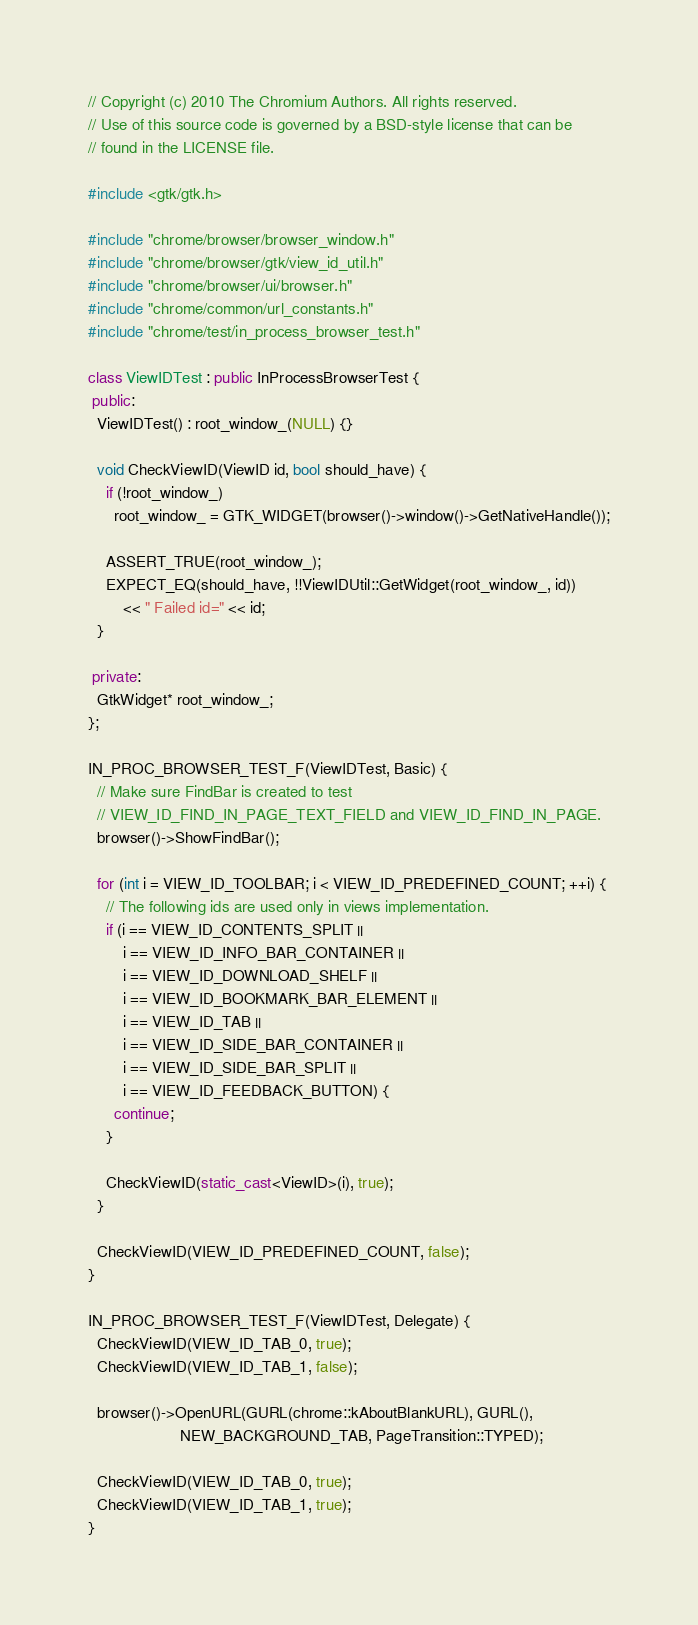<code> <loc_0><loc_0><loc_500><loc_500><_C++_>// Copyright (c) 2010 The Chromium Authors. All rights reserved.
// Use of this source code is governed by a BSD-style license that can be
// found in the LICENSE file.

#include <gtk/gtk.h>

#include "chrome/browser/browser_window.h"
#include "chrome/browser/gtk/view_id_util.h"
#include "chrome/browser/ui/browser.h"
#include "chrome/common/url_constants.h"
#include "chrome/test/in_process_browser_test.h"

class ViewIDTest : public InProcessBrowserTest {
 public:
  ViewIDTest() : root_window_(NULL) {}

  void CheckViewID(ViewID id, bool should_have) {
    if (!root_window_)
      root_window_ = GTK_WIDGET(browser()->window()->GetNativeHandle());

    ASSERT_TRUE(root_window_);
    EXPECT_EQ(should_have, !!ViewIDUtil::GetWidget(root_window_, id))
        << " Failed id=" << id;
  }

 private:
  GtkWidget* root_window_;
};

IN_PROC_BROWSER_TEST_F(ViewIDTest, Basic) {
  // Make sure FindBar is created to test
  // VIEW_ID_FIND_IN_PAGE_TEXT_FIELD and VIEW_ID_FIND_IN_PAGE.
  browser()->ShowFindBar();

  for (int i = VIEW_ID_TOOLBAR; i < VIEW_ID_PREDEFINED_COUNT; ++i) {
    // The following ids are used only in views implementation.
    if (i == VIEW_ID_CONTENTS_SPLIT ||
        i == VIEW_ID_INFO_BAR_CONTAINER ||
        i == VIEW_ID_DOWNLOAD_SHELF ||
        i == VIEW_ID_BOOKMARK_BAR_ELEMENT ||
        i == VIEW_ID_TAB ||
        i == VIEW_ID_SIDE_BAR_CONTAINER ||
        i == VIEW_ID_SIDE_BAR_SPLIT ||
        i == VIEW_ID_FEEDBACK_BUTTON) {
      continue;
    }

    CheckViewID(static_cast<ViewID>(i), true);
  }

  CheckViewID(VIEW_ID_PREDEFINED_COUNT, false);
}

IN_PROC_BROWSER_TEST_F(ViewIDTest, Delegate) {
  CheckViewID(VIEW_ID_TAB_0, true);
  CheckViewID(VIEW_ID_TAB_1, false);

  browser()->OpenURL(GURL(chrome::kAboutBlankURL), GURL(),
                     NEW_BACKGROUND_TAB, PageTransition::TYPED);

  CheckViewID(VIEW_ID_TAB_0, true);
  CheckViewID(VIEW_ID_TAB_1, true);
}
</code> 